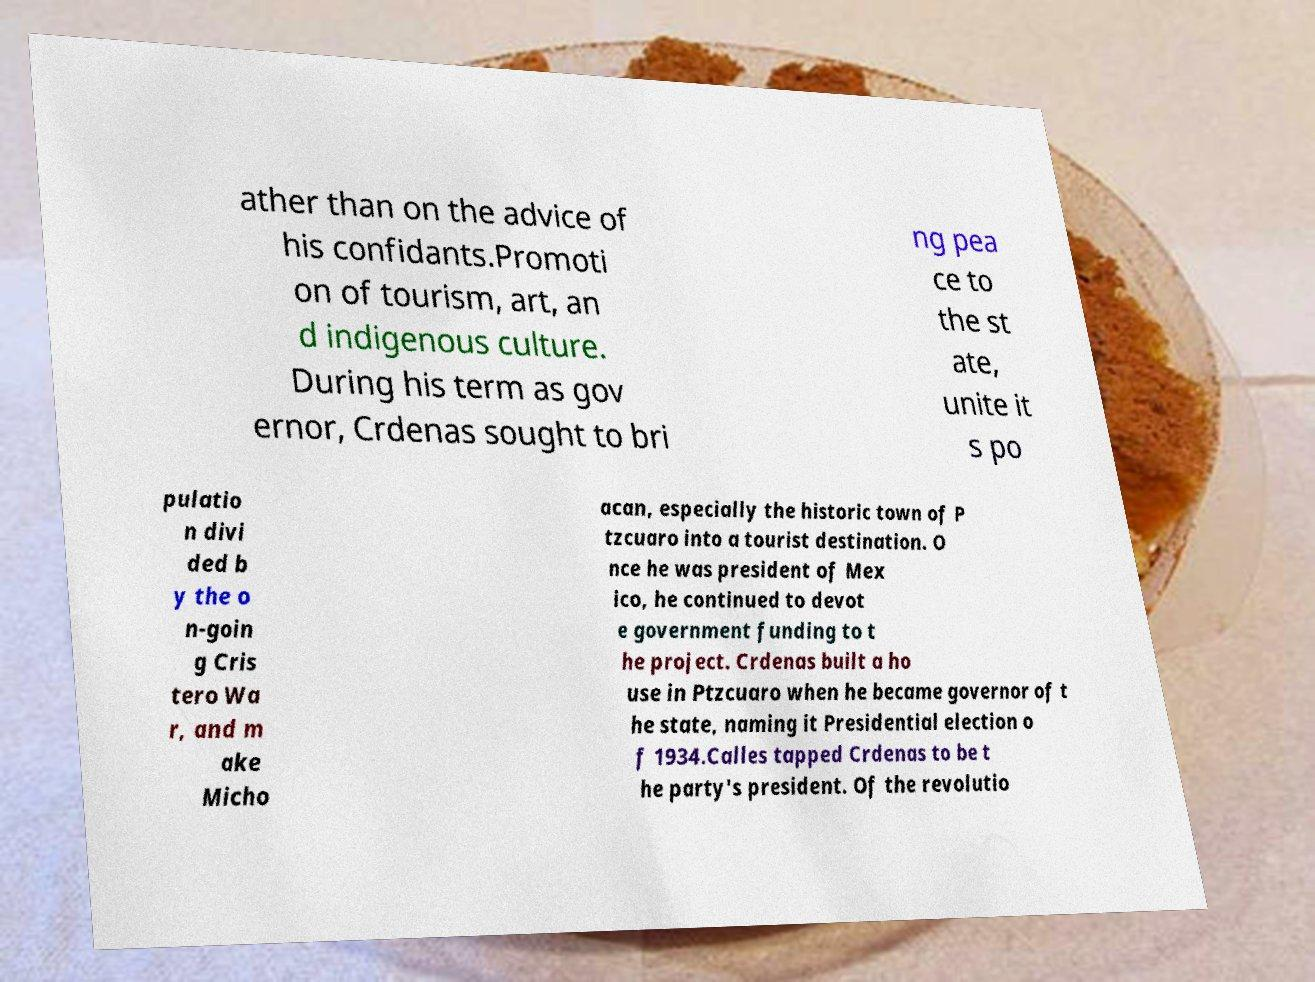Could you extract and type out the text from this image? ather than on the advice of his confidants.Promoti on of tourism, art, an d indigenous culture. During his term as gov ernor, Crdenas sought to bri ng pea ce to the st ate, unite it s po pulatio n divi ded b y the o n-goin g Cris tero Wa r, and m ake Micho acan, especially the historic town of P tzcuaro into a tourist destination. O nce he was president of Mex ico, he continued to devot e government funding to t he project. Crdenas built a ho use in Ptzcuaro when he became governor of t he state, naming it Presidential election o f 1934.Calles tapped Crdenas to be t he party's president. Of the revolutio 